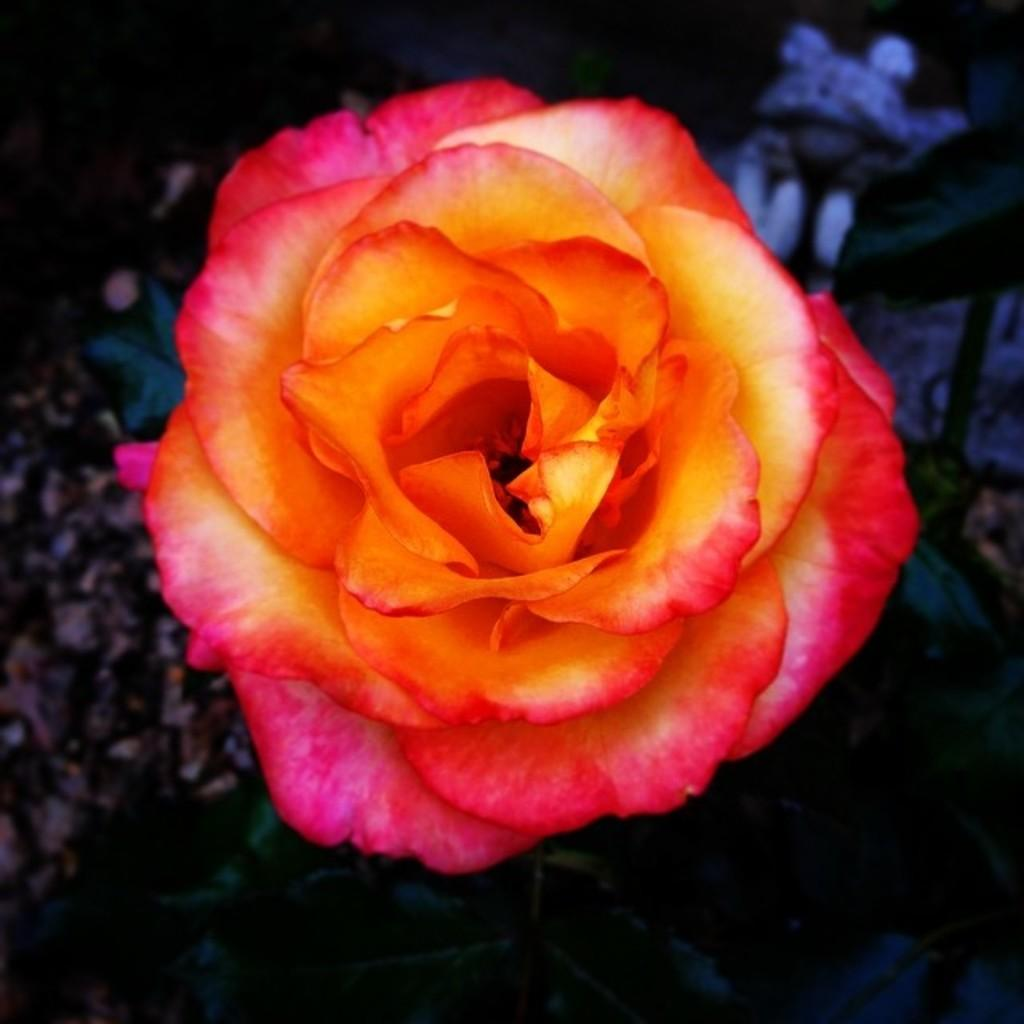What type of flower is in the image? There is a rose flower in the image. What colors can be seen on the rose flower? The rose flower has orange and pink colors. Is the rose flower part of a larger plant? Yes, the rose flower is part of a rose plant. How many attempts did the team make to cross the boundary in the image? There is no team, boundary, or attempt present in the image; it features a rose flower with orange and pink colors. 